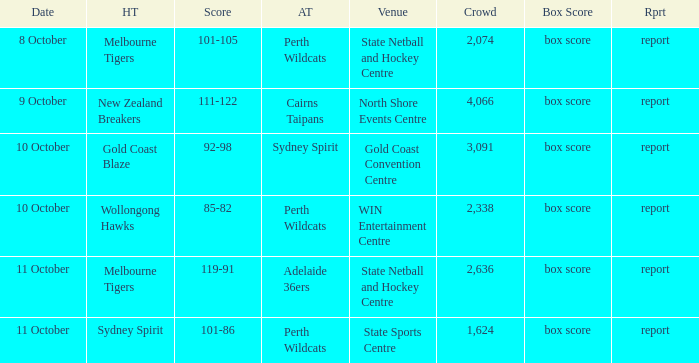Would you be able to parse every entry in this table? {'header': ['Date', 'HT', 'Score', 'AT', 'Venue', 'Crowd', 'Box Score', 'Rprt'], 'rows': [['8 October', 'Melbourne Tigers', '101-105', 'Perth Wildcats', 'State Netball and Hockey Centre', '2,074', 'box score', 'report'], ['9 October', 'New Zealand Breakers', '111-122', 'Cairns Taipans', 'North Shore Events Centre', '4,066', 'box score', 'report'], ['10 October', 'Gold Coast Blaze', '92-98', 'Sydney Spirit', 'Gold Coast Convention Centre', '3,091', 'box score', 'report'], ['10 October', 'Wollongong Hawks', '85-82', 'Perth Wildcats', 'WIN Entertainment Centre', '2,338', 'box score', 'report'], ['11 October', 'Melbourne Tigers', '119-91', 'Adelaide 36ers', 'State Netball and Hockey Centre', '2,636', 'box score', 'report'], ['11 October', 'Sydney Spirit', '101-86', 'Perth Wildcats', 'State Sports Centre', '1,624', 'box score', 'report']]} What was the crowd size for the game with a score of 101-105? 2074.0. 